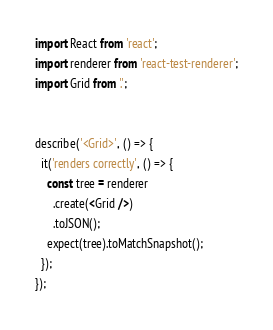Convert code to text. <code><loc_0><loc_0><loc_500><loc_500><_JavaScript_>import React from 'react';
import renderer from 'react-test-renderer';
import Grid from '.';


describe('<Grid>', () => {
  it('renders correctly', () => {
    const tree = renderer
      .create(<Grid />)
      .toJSON();
    expect(tree).toMatchSnapshot();
  });
});
</code> 